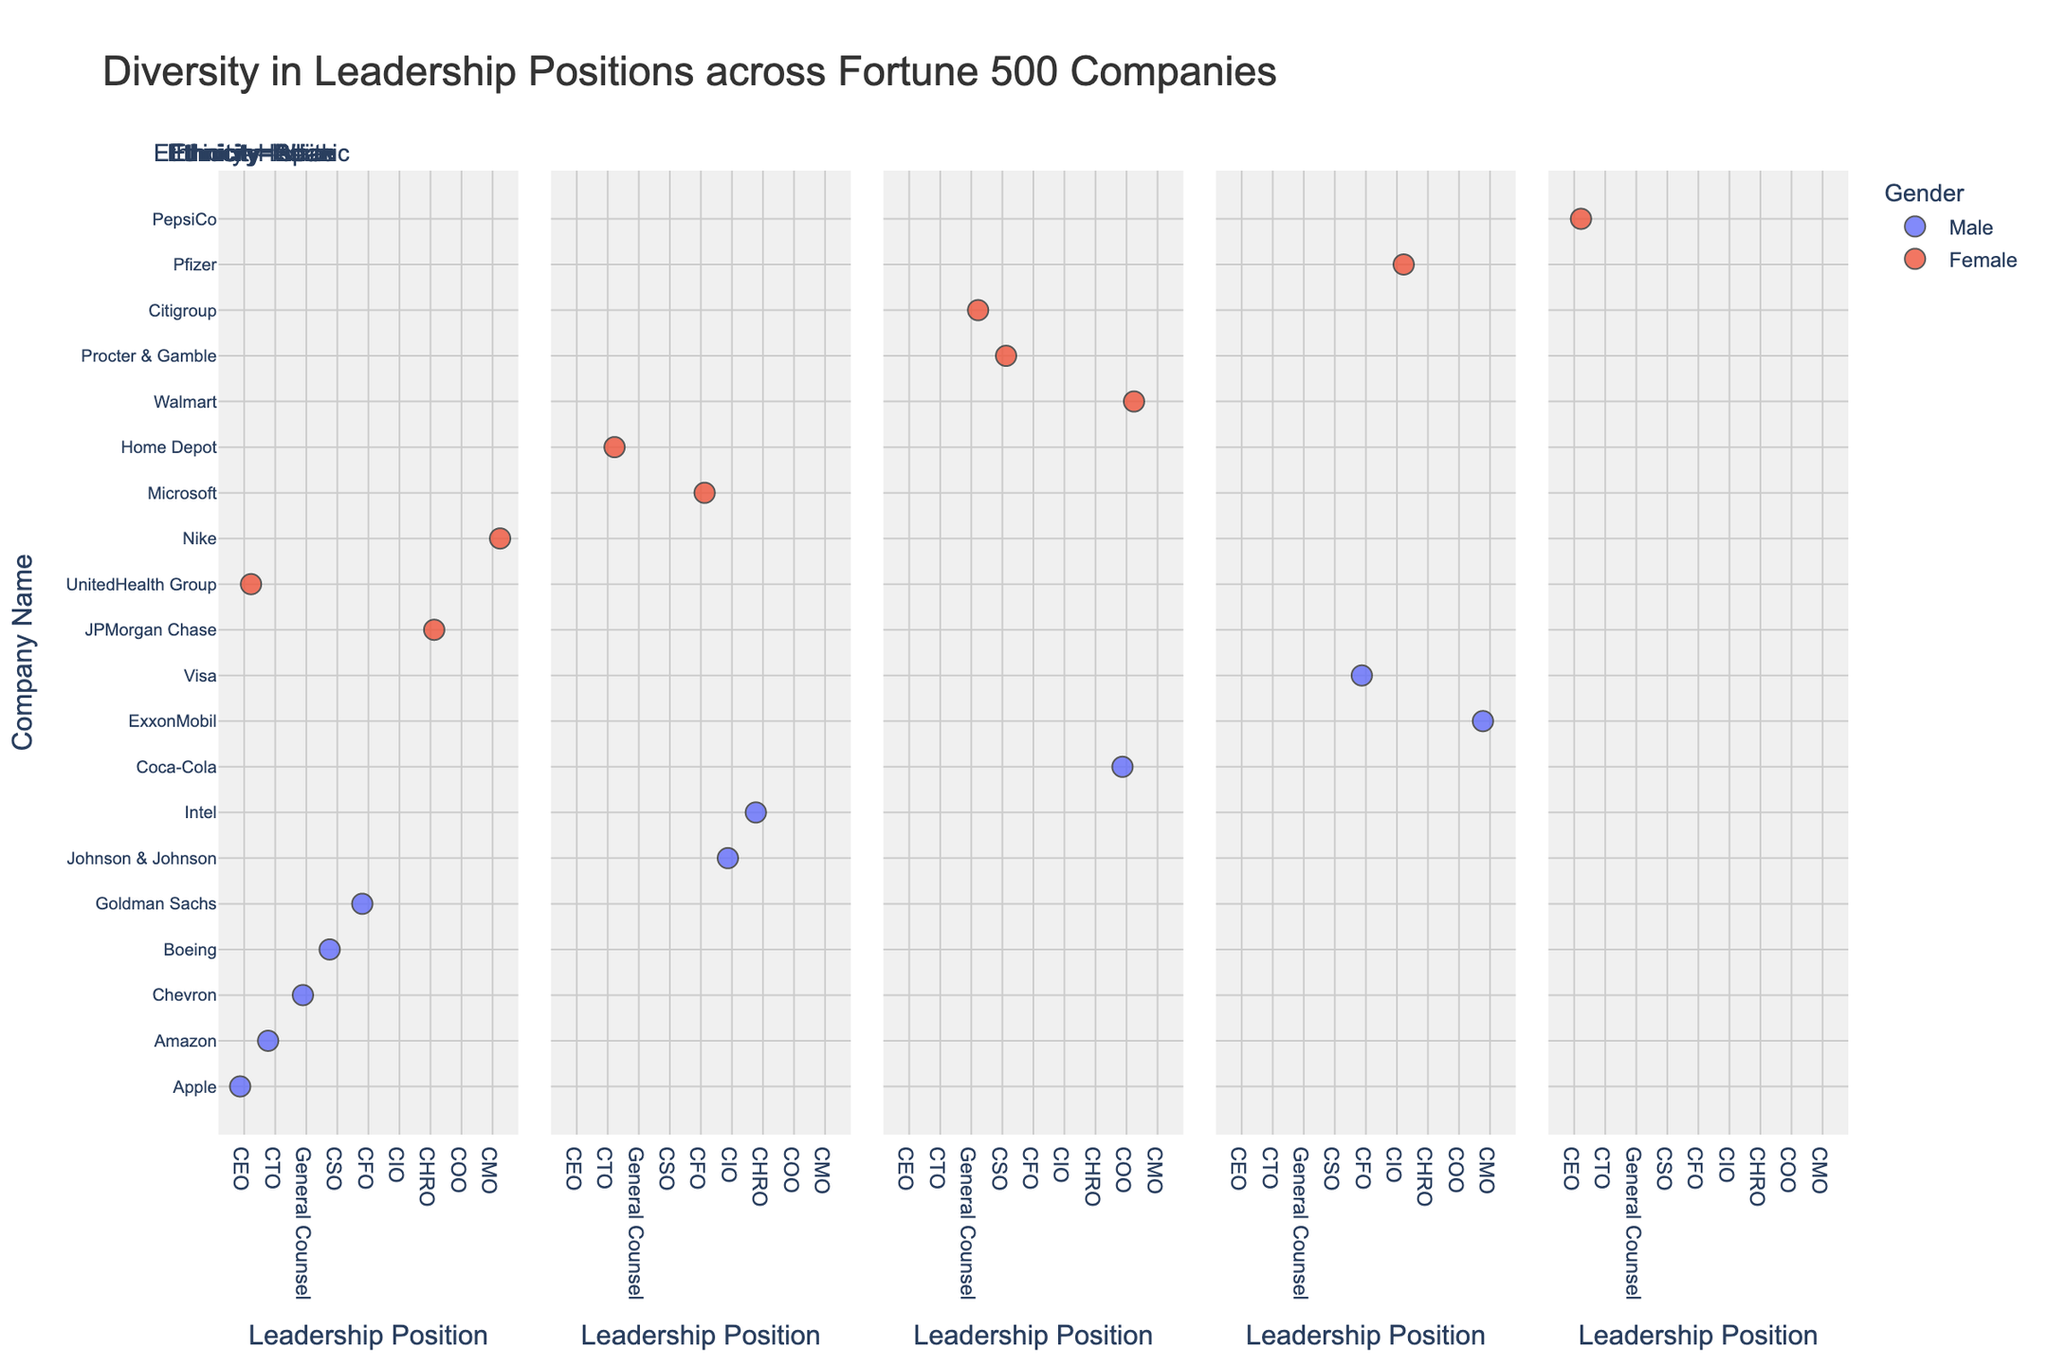How many companies’ CEOs are female? To answer this, locate all CEO positions in the plot, then count the number of data points labeled as "Female" under these positions.
Answer: 3 Which position has the highest number of Black females? Identify all data points where Gender is "Female" and Ethnicity is "Black," then count the occurrences for each position.
Answer: COO and CSO (tie) Are there more White males or Asian males in leadership positions? Observe the number of male data points in the White and Asian categories, then compare the counts.
Answer: White males Count the number of Fortune 500 companies led by a non-White CEO. Identify all CEO positions across the facets, then exclude the White CEOs to count non-White CEOs.
Answer: 1 How does the representation of Asian females compare across different positions? Locate Asian females in each position category to compare their distribution; note the number of data points for each one.
Answer: Present in CFO and CTO Which position has the most gender diversity? Look at each position category, count the gender diversity (Presence of both Male and Female), and identify the position with the highest.
Answer: CIO, CHRO, General Counsel, CEO, COO, CMO (tie) How many companies have Hispanic representation in their leadership positions? Count the distinct companies with data points in the Hispanic facet.
Answer: 4 Is the gender distribution among CTOs balanced? Count the number of male and female CTOs, then compare the quantities.
Answer: Yes (One male and one female) What is the most common ethnicity among CFOs? Within the CFO position, count the data points for each ethnicity to identify the most frequent one.
Answer: White Are there more Black males or Hispanic females in leadership roles? Look at the counts of data points for Black males and for Hispanic females in the respective facets, then compare them.
Answer: Black males 